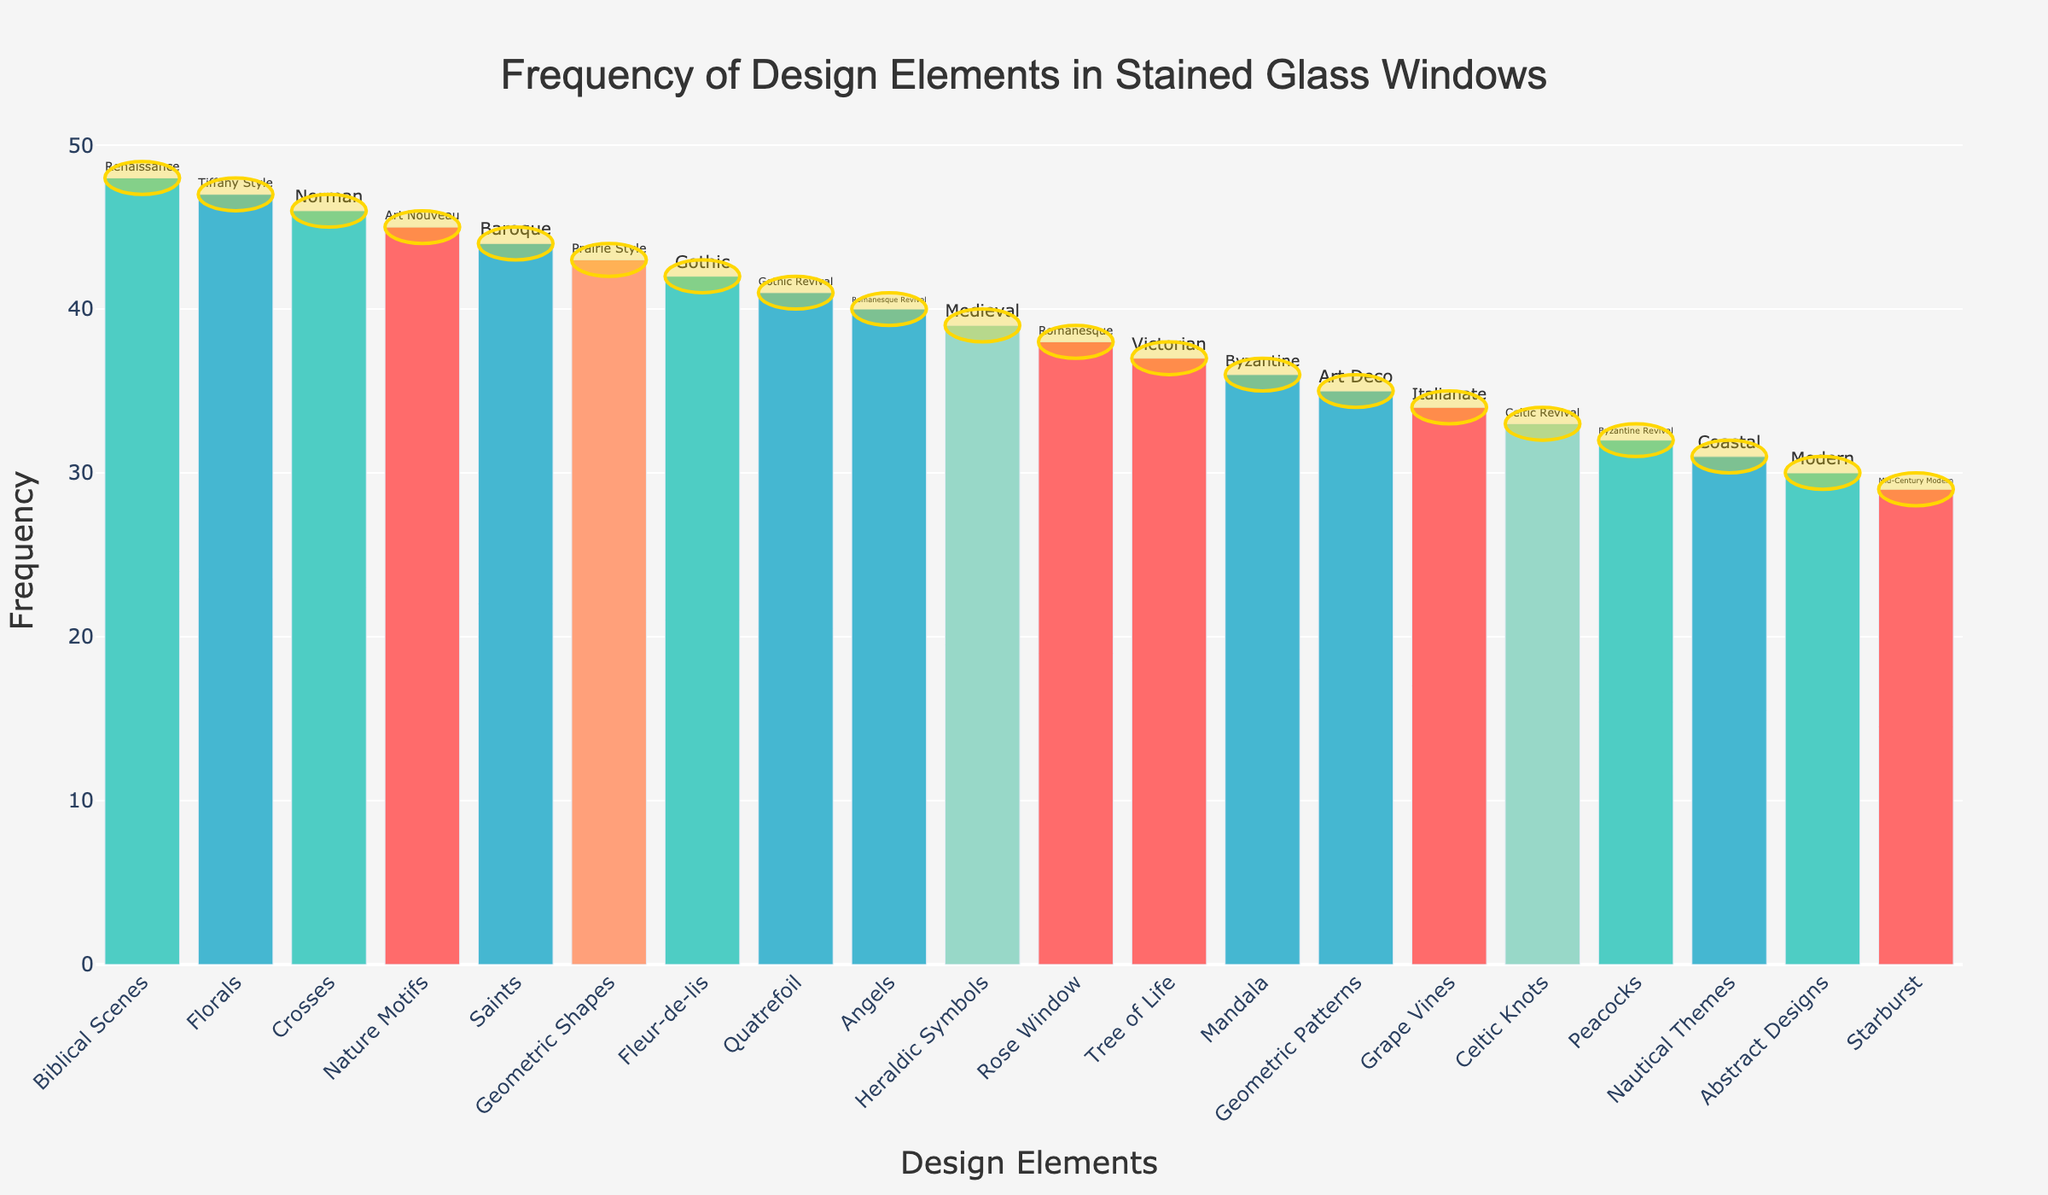What's the title of the figure? The title is usually displayed at the top of the figure, and in this case, it should clearly state what the plot is about.
Answer: Frequency of Design Elements in Stained Glass Windows How many design elements are illustrated in the plot? Count the number of bars in the plot. Each bar represents a different design element. There are 20 distinct bars, hence 20 design elements.
Answer: 20 Which design element has the highest frequency? Look for the tallest bar in the plot and note the design element it represents. The tallest bar represents "Biblical Scenes".
Answer: Biblical Scenes Which architectural style does "Fleur-de-lis" belong to, and what's its frequency? Find the bar labeled "Fleur-de-lis" and refer to its text label for the associated architectural style and its frequency. It typically appears above or beside the bar.
Answer: Gothic, 42 What is the combined frequency of the top three design elements? Identify the three tallest bars, then sum their frequencies. The frequencies are Biblical Scenes (48), Florals (47), and Crosses (46). The combined frequency is 48 + 47 + 46 = 141.
Answer: 141 Which design element has a frequency of 31, and what is its architectural style? Look for the bar with the height corresponding to the frequency value of 31. The bar represents "Nautical Themes", and its architectural style is Coastal.
Answer: Nautical Themes, Coastal What is the frequency difference between the highest and lowest design elements? Subtract the frequency of the lowest bar (Starburst, 29) from the highest (Biblical Scenes, 48). The difference is 48 - 29 = 19.
Answer: 19 Which design elements are used in Byzantine architectural style, and what's their combined frequency? Identify the bars that belong to the Byzantine and Byzantine Revival architectural styles. These are "Mandala" (36) and "Peacocks" (32). The combined frequency is 36 + 32 = 68.
Answer: Mandala and Peacocks, 68 What percentage of the total design elements does "Art Nouveau" style contribute? Find the frequency of the "Nature Motifs" (Art Nouveau, 45), then divide by the total sum of all frequencies and multiply by 100 to get the percentage. Sum of all frequencies is 745. Percentage is (45 / 745) * 100 ≈ 6.04%.
Answer: 6.04% Compare the frequencies of "Gothic" and "Gothic Revival" design elements. Which one is higher and by how much? Find the frequencies of "Fleur-de-lis" (Gothic, 42) and "Quatrefoil" (Gothic Revival, 41). The difference is 42 - 41 = 1. "Gothic" has the higher frequency.
Answer: Gothic by 1 